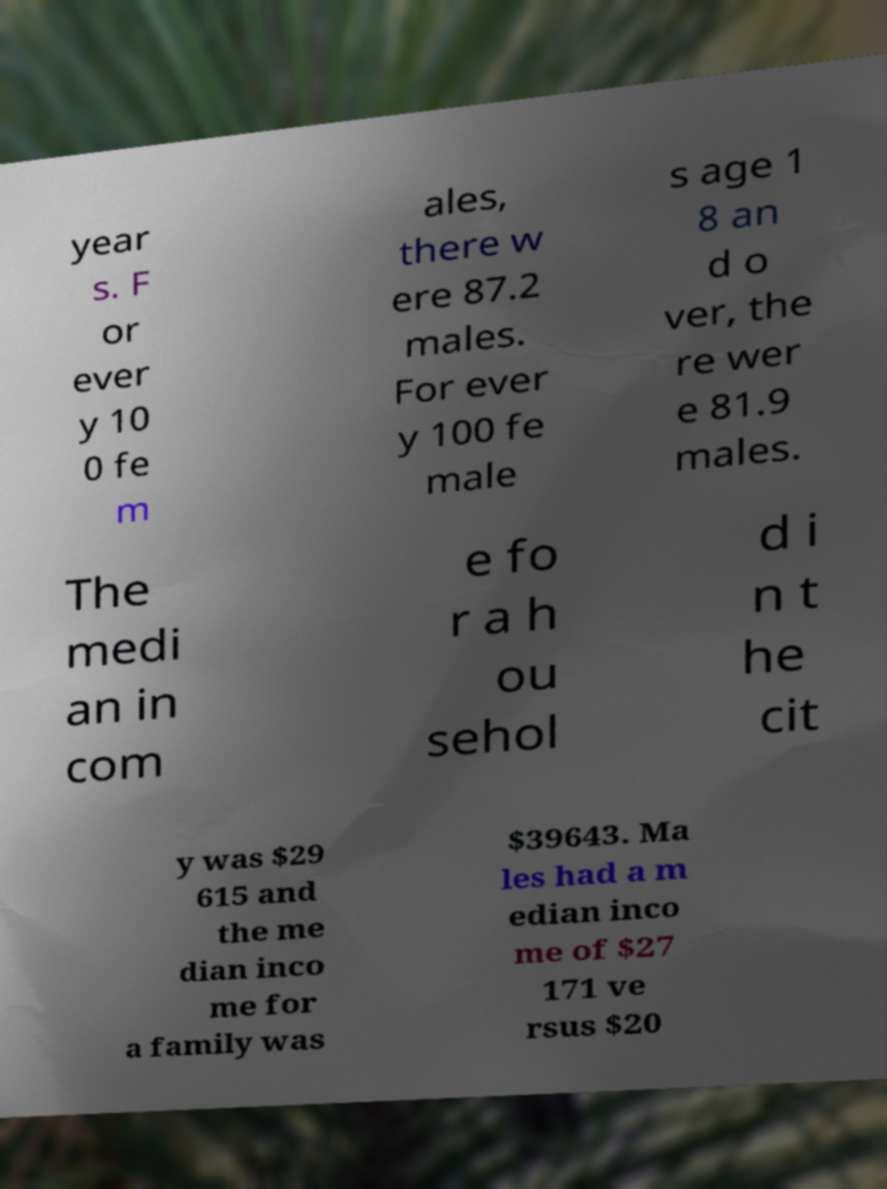There's text embedded in this image that I need extracted. Can you transcribe it verbatim? year s. F or ever y 10 0 fe m ales, there w ere 87.2 males. For ever y 100 fe male s age 1 8 an d o ver, the re wer e 81.9 males. The medi an in com e fo r a h ou sehol d i n t he cit y was $29 615 and the me dian inco me for a family was $39643. Ma les had a m edian inco me of $27 171 ve rsus $20 